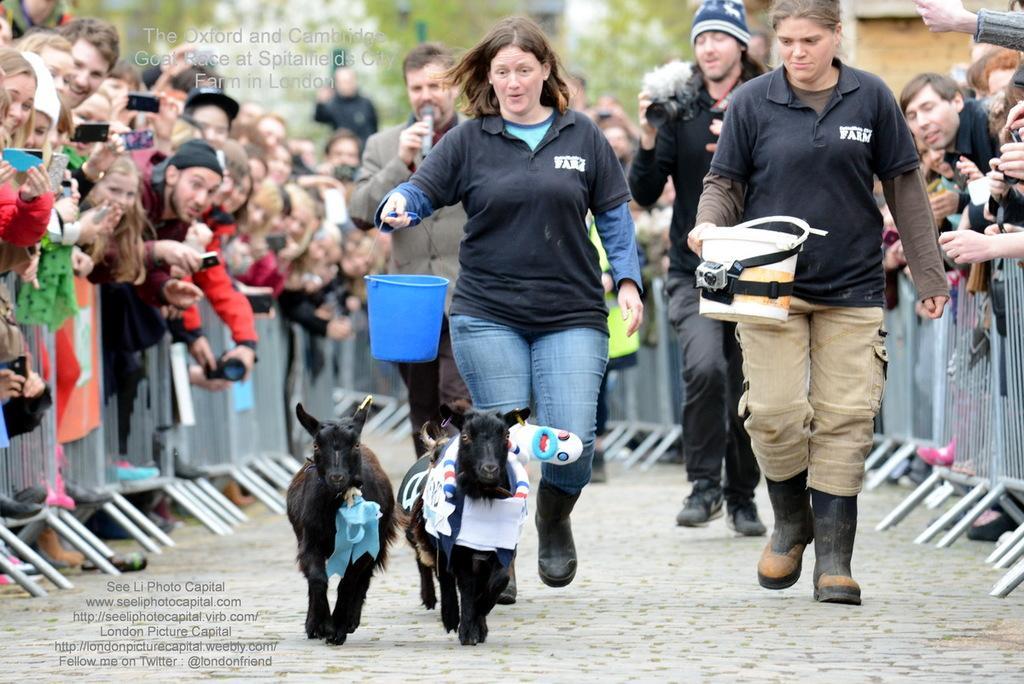How would you summarize this image in a sentence or two? In this image there are two animals walking on the path behind them there are few people holding objects in their hands and following the animals. On the right and left side of the image there are few spectators and railing in front of them. 